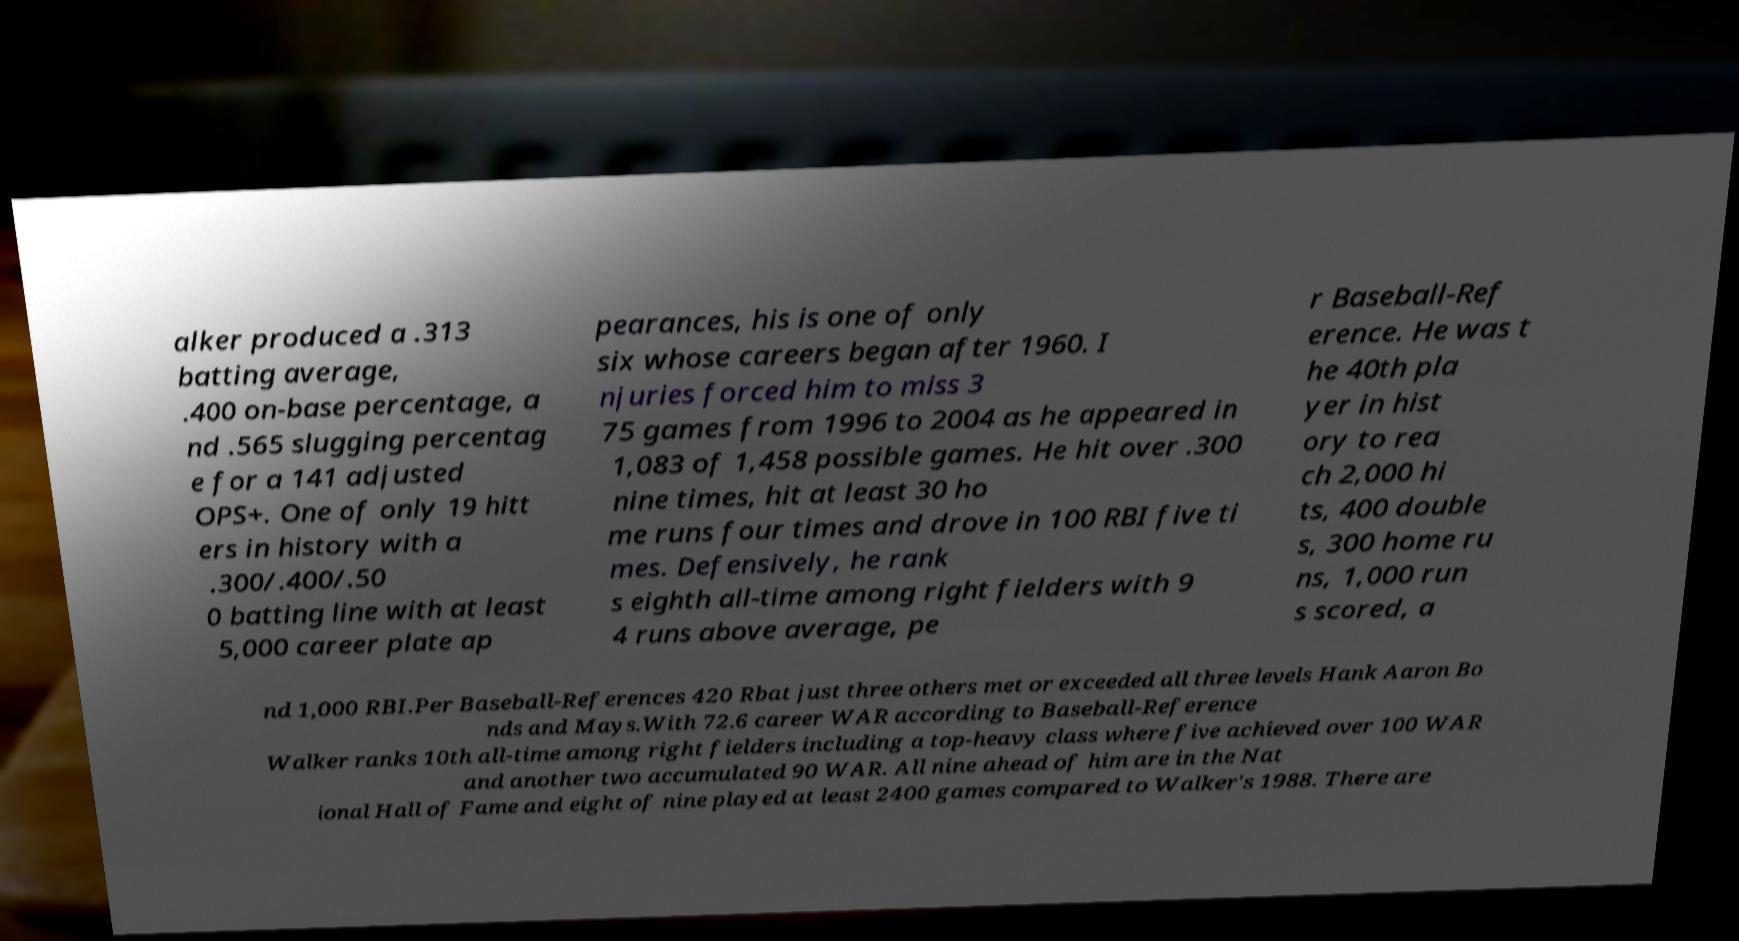I need the written content from this picture converted into text. Can you do that? alker produced a .313 batting average, .400 on-base percentage, a nd .565 slugging percentag e for a 141 adjusted OPS+. One of only 19 hitt ers in history with a .300/.400/.50 0 batting line with at least 5,000 career plate ap pearances, his is one of only six whose careers began after 1960. I njuries forced him to miss 3 75 games from 1996 to 2004 as he appeared in 1,083 of 1,458 possible games. He hit over .300 nine times, hit at least 30 ho me runs four times and drove in 100 RBI five ti mes. Defensively, he rank s eighth all-time among right fielders with 9 4 runs above average, pe r Baseball-Ref erence. He was t he 40th pla yer in hist ory to rea ch 2,000 hi ts, 400 double s, 300 home ru ns, 1,000 run s scored, a nd 1,000 RBI.Per Baseball-References 420 Rbat just three others met or exceeded all three levels Hank Aaron Bo nds and Mays.With 72.6 career WAR according to Baseball-Reference Walker ranks 10th all-time among right fielders including a top-heavy class where five achieved over 100 WAR and another two accumulated 90 WAR. All nine ahead of him are in the Nat ional Hall of Fame and eight of nine played at least 2400 games compared to Walker's 1988. There are 